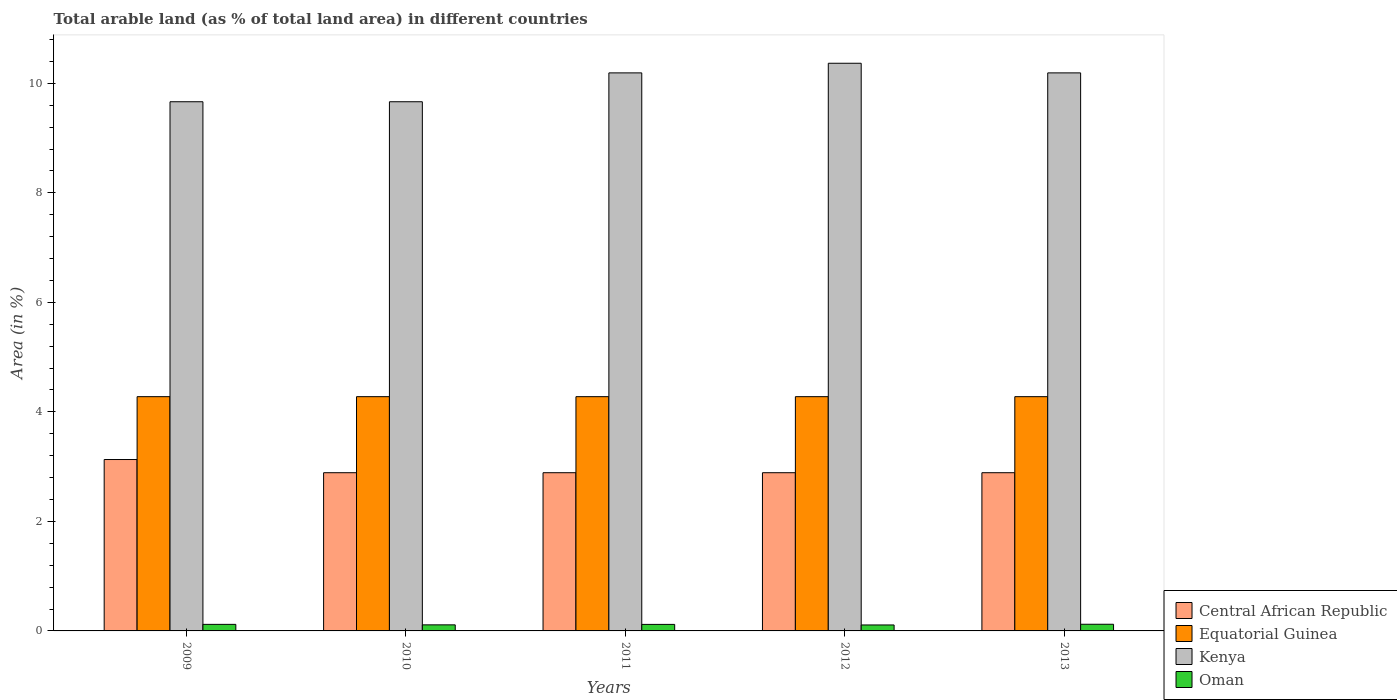How many groups of bars are there?
Provide a succinct answer. 5. Are the number of bars on each tick of the X-axis equal?
Your answer should be very brief. Yes. How many bars are there on the 3rd tick from the left?
Ensure brevity in your answer.  4. What is the label of the 4th group of bars from the left?
Provide a succinct answer. 2012. In how many cases, is the number of bars for a given year not equal to the number of legend labels?
Ensure brevity in your answer.  0. What is the percentage of arable land in Central African Republic in 2013?
Provide a short and direct response. 2.89. Across all years, what is the maximum percentage of arable land in Oman?
Offer a very short reply. 0.12. Across all years, what is the minimum percentage of arable land in Central African Republic?
Make the answer very short. 2.89. What is the total percentage of arable land in Central African Republic in the graph?
Provide a short and direct response. 14.69. What is the difference between the percentage of arable land in Oman in 2010 and that in 2013?
Keep it short and to the point. -0.01. What is the difference between the percentage of arable land in Equatorial Guinea in 2009 and the percentage of arable land in Kenya in 2013?
Your response must be concise. -5.91. What is the average percentage of arable land in Central African Republic per year?
Provide a succinct answer. 2.94. In the year 2012, what is the difference between the percentage of arable land in Oman and percentage of arable land in Kenya?
Your response must be concise. -10.26. Is the percentage of arable land in Kenya in 2009 less than that in 2012?
Provide a succinct answer. Yes. Is the difference between the percentage of arable land in Oman in 2009 and 2010 greater than the difference between the percentage of arable land in Kenya in 2009 and 2010?
Offer a terse response. Yes. What is the difference between the highest and the second highest percentage of arable land in Kenya?
Offer a terse response. 0.18. In how many years, is the percentage of arable land in Oman greater than the average percentage of arable land in Oman taken over all years?
Provide a short and direct response. 3. Is the sum of the percentage of arable land in Central African Republic in 2011 and 2013 greater than the maximum percentage of arable land in Kenya across all years?
Offer a terse response. No. What does the 1st bar from the left in 2013 represents?
Offer a very short reply. Central African Republic. What does the 2nd bar from the right in 2012 represents?
Keep it short and to the point. Kenya. How many bars are there?
Provide a short and direct response. 20. Are all the bars in the graph horizontal?
Your response must be concise. No. How many years are there in the graph?
Offer a terse response. 5. What is the difference between two consecutive major ticks on the Y-axis?
Ensure brevity in your answer.  2. Are the values on the major ticks of Y-axis written in scientific E-notation?
Provide a short and direct response. No. Where does the legend appear in the graph?
Offer a very short reply. Bottom right. What is the title of the graph?
Give a very brief answer. Total arable land (as % of total land area) in different countries. What is the label or title of the Y-axis?
Ensure brevity in your answer.  Area (in %). What is the Area (in %) of Central African Republic in 2009?
Provide a short and direct response. 3.13. What is the Area (in %) of Equatorial Guinea in 2009?
Offer a very short reply. 4.28. What is the Area (in %) of Kenya in 2009?
Offer a very short reply. 9.66. What is the Area (in %) in Oman in 2009?
Ensure brevity in your answer.  0.12. What is the Area (in %) of Central African Republic in 2010?
Your response must be concise. 2.89. What is the Area (in %) of Equatorial Guinea in 2010?
Keep it short and to the point. 4.28. What is the Area (in %) in Kenya in 2010?
Offer a terse response. 9.66. What is the Area (in %) in Oman in 2010?
Provide a succinct answer. 0.11. What is the Area (in %) in Central African Republic in 2011?
Give a very brief answer. 2.89. What is the Area (in %) in Equatorial Guinea in 2011?
Offer a terse response. 4.28. What is the Area (in %) in Kenya in 2011?
Your response must be concise. 10.19. What is the Area (in %) in Oman in 2011?
Offer a very short reply. 0.12. What is the Area (in %) of Central African Republic in 2012?
Your answer should be very brief. 2.89. What is the Area (in %) of Equatorial Guinea in 2012?
Provide a succinct answer. 4.28. What is the Area (in %) in Kenya in 2012?
Provide a short and direct response. 10.37. What is the Area (in %) in Oman in 2012?
Offer a terse response. 0.11. What is the Area (in %) of Central African Republic in 2013?
Your answer should be very brief. 2.89. What is the Area (in %) of Equatorial Guinea in 2013?
Provide a short and direct response. 4.28. What is the Area (in %) of Kenya in 2013?
Keep it short and to the point. 10.19. What is the Area (in %) in Oman in 2013?
Make the answer very short. 0.12. Across all years, what is the maximum Area (in %) of Central African Republic?
Your response must be concise. 3.13. Across all years, what is the maximum Area (in %) in Equatorial Guinea?
Ensure brevity in your answer.  4.28. Across all years, what is the maximum Area (in %) of Kenya?
Your answer should be compact. 10.37. Across all years, what is the maximum Area (in %) in Oman?
Provide a succinct answer. 0.12. Across all years, what is the minimum Area (in %) in Central African Republic?
Make the answer very short. 2.89. Across all years, what is the minimum Area (in %) in Equatorial Guinea?
Ensure brevity in your answer.  4.28. Across all years, what is the minimum Area (in %) of Kenya?
Your answer should be very brief. 9.66. Across all years, what is the minimum Area (in %) in Oman?
Your response must be concise. 0.11. What is the total Area (in %) of Central African Republic in the graph?
Your response must be concise. 14.69. What is the total Area (in %) of Equatorial Guinea in the graph?
Provide a short and direct response. 21.39. What is the total Area (in %) of Kenya in the graph?
Offer a terse response. 50.08. What is the total Area (in %) of Oman in the graph?
Make the answer very short. 0.58. What is the difference between the Area (in %) in Central African Republic in 2009 and that in 2010?
Offer a terse response. 0.24. What is the difference between the Area (in %) in Oman in 2009 and that in 2010?
Provide a short and direct response. 0.01. What is the difference between the Area (in %) of Central African Republic in 2009 and that in 2011?
Your answer should be very brief. 0.24. What is the difference between the Area (in %) in Equatorial Guinea in 2009 and that in 2011?
Give a very brief answer. 0. What is the difference between the Area (in %) of Kenya in 2009 and that in 2011?
Provide a short and direct response. -0.53. What is the difference between the Area (in %) of Oman in 2009 and that in 2011?
Your answer should be very brief. 0. What is the difference between the Area (in %) in Central African Republic in 2009 and that in 2012?
Provide a succinct answer. 0.24. What is the difference between the Area (in %) of Kenya in 2009 and that in 2012?
Your answer should be very brief. -0.7. What is the difference between the Area (in %) in Oman in 2009 and that in 2012?
Offer a very short reply. 0.01. What is the difference between the Area (in %) in Central African Republic in 2009 and that in 2013?
Your answer should be very brief. 0.24. What is the difference between the Area (in %) in Equatorial Guinea in 2009 and that in 2013?
Provide a succinct answer. 0. What is the difference between the Area (in %) in Kenya in 2009 and that in 2013?
Provide a short and direct response. -0.53. What is the difference between the Area (in %) in Oman in 2009 and that in 2013?
Your answer should be very brief. -0. What is the difference between the Area (in %) of Kenya in 2010 and that in 2011?
Your answer should be very brief. -0.53. What is the difference between the Area (in %) of Oman in 2010 and that in 2011?
Give a very brief answer. -0.01. What is the difference between the Area (in %) of Equatorial Guinea in 2010 and that in 2012?
Make the answer very short. 0. What is the difference between the Area (in %) in Kenya in 2010 and that in 2012?
Your response must be concise. -0.7. What is the difference between the Area (in %) of Oman in 2010 and that in 2012?
Your answer should be very brief. 0. What is the difference between the Area (in %) of Central African Republic in 2010 and that in 2013?
Offer a terse response. 0. What is the difference between the Area (in %) of Kenya in 2010 and that in 2013?
Your response must be concise. -0.53. What is the difference between the Area (in %) of Oman in 2010 and that in 2013?
Your response must be concise. -0.01. What is the difference between the Area (in %) of Central African Republic in 2011 and that in 2012?
Your response must be concise. 0. What is the difference between the Area (in %) of Kenya in 2011 and that in 2012?
Your answer should be compact. -0.18. What is the difference between the Area (in %) of Oman in 2011 and that in 2012?
Give a very brief answer. 0.01. What is the difference between the Area (in %) of Kenya in 2011 and that in 2013?
Keep it short and to the point. 0. What is the difference between the Area (in %) of Oman in 2011 and that in 2013?
Provide a succinct answer. -0. What is the difference between the Area (in %) in Equatorial Guinea in 2012 and that in 2013?
Give a very brief answer. 0. What is the difference between the Area (in %) in Kenya in 2012 and that in 2013?
Your answer should be very brief. 0.18. What is the difference between the Area (in %) in Oman in 2012 and that in 2013?
Your answer should be very brief. -0.01. What is the difference between the Area (in %) of Central African Republic in 2009 and the Area (in %) of Equatorial Guinea in 2010?
Give a very brief answer. -1.15. What is the difference between the Area (in %) in Central African Republic in 2009 and the Area (in %) in Kenya in 2010?
Ensure brevity in your answer.  -6.53. What is the difference between the Area (in %) of Central African Republic in 2009 and the Area (in %) of Oman in 2010?
Make the answer very short. 3.02. What is the difference between the Area (in %) of Equatorial Guinea in 2009 and the Area (in %) of Kenya in 2010?
Keep it short and to the point. -5.39. What is the difference between the Area (in %) in Equatorial Guinea in 2009 and the Area (in %) in Oman in 2010?
Your answer should be compact. 4.17. What is the difference between the Area (in %) of Kenya in 2009 and the Area (in %) of Oman in 2010?
Provide a short and direct response. 9.55. What is the difference between the Area (in %) in Central African Republic in 2009 and the Area (in %) in Equatorial Guinea in 2011?
Your answer should be compact. -1.15. What is the difference between the Area (in %) in Central African Republic in 2009 and the Area (in %) in Kenya in 2011?
Your answer should be very brief. -7.06. What is the difference between the Area (in %) of Central African Republic in 2009 and the Area (in %) of Oman in 2011?
Ensure brevity in your answer.  3.01. What is the difference between the Area (in %) in Equatorial Guinea in 2009 and the Area (in %) in Kenya in 2011?
Ensure brevity in your answer.  -5.91. What is the difference between the Area (in %) in Equatorial Guinea in 2009 and the Area (in %) in Oman in 2011?
Provide a succinct answer. 4.16. What is the difference between the Area (in %) in Kenya in 2009 and the Area (in %) in Oman in 2011?
Keep it short and to the point. 9.54. What is the difference between the Area (in %) of Central African Republic in 2009 and the Area (in %) of Equatorial Guinea in 2012?
Offer a terse response. -1.15. What is the difference between the Area (in %) of Central African Republic in 2009 and the Area (in %) of Kenya in 2012?
Make the answer very short. -7.24. What is the difference between the Area (in %) of Central African Republic in 2009 and the Area (in %) of Oman in 2012?
Provide a short and direct response. 3.02. What is the difference between the Area (in %) of Equatorial Guinea in 2009 and the Area (in %) of Kenya in 2012?
Your answer should be compact. -6.09. What is the difference between the Area (in %) in Equatorial Guinea in 2009 and the Area (in %) in Oman in 2012?
Make the answer very short. 4.17. What is the difference between the Area (in %) in Kenya in 2009 and the Area (in %) in Oman in 2012?
Offer a terse response. 9.55. What is the difference between the Area (in %) in Central African Republic in 2009 and the Area (in %) in Equatorial Guinea in 2013?
Offer a terse response. -1.15. What is the difference between the Area (in %) of Central African Republic in 2009 and the Area (in %) of Kenya in 2013?
Provide a succinct answer. -7.06. What is the difference between the Area (in %) of Central African Republic in 2009 and the Area (in %) of Oman in 2013?
Your response must be concise. 3.01. What is the difference between the Area (in %) in Equatorial Guinea in 2009 and the Area (in %) in Kenya in 2013?
Keep it short and to the point. -5.91. What is the difference between the Area (in %) of Equatorial Guinea in 2009 and the Area (in %) of Oman in 2013?
Give a very brief answer. 4.16. What is the difference between the Area (in %) of Kenya in 2009 and the Area (in %) of Oman in 2013?
Keep it short and to the point. 9.54. What is the difference between the Area (in %) in Central African Republic in 2010 and the Area (in %) in Equatorial Guinea in 2011?
Give a very brief answer. -1.39. What is the difference between the Area (in %) of Central African Republic in 2010 and the Area (in %) of Kenya in 2011?
Provide a short and direct response. -7.3. What is the difference between the Area (in %) of Central African Republic in 2010 and the Area (in %) of Oman in 2011?
Provide a short and direct response. 2.77. What is the difference between the Area (in %) of Equatorial Guinea in 2010 and the Area (in %) of Kenya in 2011?
Your response must be concise. -5.91. What is the difference between the Area (in %) in Equatorial Guinea in 2010 and the Area (in %) in Oman in 2011?
Give a very brief answer. 4.16. What is the difference between the Area (in %) of Kenya in 2010 and the Area (in %) of Oman in 2011?
Provide a short and direct response. 9.54. What is the difference between the Area (in %) in Central African Republic in 2010 and the Area (in %) in Equatorial Guinea in 2012?
Ensure brevity in your answer.  -1.39. What is the difference between the Area (in %) in Central African Republic in 2010 and the Area (in %) in Kenya in 2012?
Ensure brevity in your answer.  -7.48. What is the difference between the Area (in %) in Central African Republic in 2010 and the Area (in %) in Oman in 2012?
Make the answer very short. 2.78. What is the difference between the Area (in %) of Equatorial Guinea in 2010 and the Area (in %) of Kenya in 2012?
Make the answer very short. -6.09. What is the difference between the Area (in %) of Equatorial Guinea in 2010 and the Area (in %) of Oman in 2012?
Offer a terse response. 4.17. What is the difference between the Area (in %) in Kenya in 2010 and the Area (in %) in Oman in 2012?
Your answer should be very brief. 9.55. What is the difference between the Area (in %) in Central African Republic in 2010 and the Area (in %) in Equatorial Guinea in 2013?
Your answer should be very brief. -1.39. What is the difference between the Area (in %) of Central African Republic in 2010 and the Area (in %) of Kenya in 2013?
Your answer should be very brief. -7.3. What is the difference between the Area (in %) of Central African Republic in 2010 and the Area (in %) of Oman in 2013?
Keep it short and to the point. 2.77. What is the difference between the Area (in %) in Equatorial Guinea in 2010 and the Area (in %) in Kenya in 2013?
Your response must be concise. -5.91. What is the difference between the Area (in %) in Equatorial Guinea in 2010 and the Area (in %) in Oman in 2013?
Keep it short and to the point. 4.16. What is the difference between the Area (in %) in Kenya in 2010 and the Area (in %) in Oman in 2013?
Your response must be concise. 9.54. What is the difference between the Area (in %) of Central African Republic in 2011 and the Area (in %) of Equatorial Guinea in 2012?
Your response must be concise. -1.39. What is the difference between the Area (in %) in Central African Republic in 2011 and the Area (in %) in Kenya in 2012?
Your answer should be compact. -7.48. What is the difference between the Area (in %) in Central African Republic in 2011 and the Area (in %) in Oman in 2012?
Your answer should be compact. 2.78. What is the difference between the Area (in %) in Equatorial Guinea in 2011 and the Area (in %) in Kenya in 2012?
Keep it short and to the point. -6.09. What is the difference between the Area (in %) in Equatorial Guinea in 2011 and the Area (in %) in Oman in 2012?
Your response must be concise. 4.17. What is the difference between the Area (in %) of Kenya in 2011 and the Area (in %) of Oman in 2012?
Give a very brief answer. 10.08. What is the difference between the Area (in %) in Central African Republic in 2011 and the Area (in %) in Equatorial Guinea in 2013?
Offer a very short reply. -1.39. What is the difference between the Area (in %) of Central African Republic in 2011 and the Area (in %) of Kenya in 2013?
Make the answer very short. -7.3. What is the difference between the Area (in %) in Central African Republic in 2011 and the Area (in %) in Oman in 2013?
Offer a terse response. 2.77. What is the difference between the Area (in %) of Equatorial Guinea in 2011 and the Area (in %) of Kenya in 2013?
Ensure brevity in your answer.  -5.91. What is the difference between the Area (in %) of Equatorial Guinea in 2011 and the Area (in %) of Oman in 2013?
Make the answer very short. 4.16. What is the difference between the Area (in %) in Kenya in 2011 and the Area (in %) in Oman in 2013?
Keep it short and to the point. 10.07. What is the difference between the Area (in %) of Central African Republic in 2012 and the Area (in %) of Equatorial Guinea in 2013?
Offer a very short reply. -1.39. What is the difference between the Area (in %) in Central African Republic in 2012 and the Area (in %) in Kenya in 2013?
Provide a succinct answer. -7.3. What is the difference between the Area (in %) of Central African Republic in 2012 and the Area (in %) of Oman in 2013?
Provide a short and direct response. 2.77. What is the difference between the Area (in %) in Equatorial Guinea in 2012 and the Area (in %) in Kenya in 2013?
Your answer should be very brief. -5.91. What is the difference between the Area (in %) of Equatorial Guinea in 2012 and the Area (in %) of Oman in 2013?
Make the answer very short. 4.16. What is the difference between the Area (in %) of Kenya in 2012 and the Area (in %) of Oman in 2013?
Your response must be concise. 10.24. What is the average Area (in %) of Central African Republic per year?
Keep it short and to the point. 2.94. What is the average Area (in %) in Equatorial Guinea per year?
Provide a short and direct response. 4.28. What is the average Area (in %) in Kenya per year?
Your answer should be very brief. 10.02. What is the average Area (in %) of Oman per year?
Ensure brevity in your answer.  0.12. In the year 2009, what is the difference between the Area (in %) of Central African Republic and Area (in %) of Equatorial Guinea?
Provide a succinct answer. -1.15. In the year 2009, what is the difference between the Area (in %) of Central African Republic and Area (in %) of Kenya?
Ensure brevity in your answer.  -6.53. In the year 2009, what is the difference between the Area (in %) of Central African Republic and Area (in %) of Oman?
Give a very brief answer. 3.01. In the year 2009, what is the difference between the Area (in %) in Equatorial Guinea and Area (in %) in Kenya?
Keep it short and to the point. -5.39. In the year 2009, what is the difference between the Area (in %) of Equatorial Guinea and Area (in %) of Oman?
Offer a very short reply. 4.16. In the year 2009, what is the difference between the Area (in %) in Kenya and Area (in %) in Oman?
Make the answer very short. 9.54. In the year 2010, what is the difference between the Area (in %) of Central African Republic and Area (in %) of Equatorial Guinea?
Offer a very short reply. -1.39. In the year 2010, what is the difference between the Area (in %) in Central African Republic and Area (in %) in Kenya?
Keep it short and to the point. -6.77. In the year 2010, what is the difference between the Area (in %) in Central African Republic and Area (in %) in Oman?
Provide a short and direct response. 2.78. In the year 2010, what is the difference between the Area (in %) in Equatorial Guinea and Area (in %) in Kenya?
Your answer should be very brief. -5.39. In the year 2010, what is the difference between the Area (in %) of Equatorial Guinea and Area (in %) of Oman?
Your answer should be compact. 4.17. In the year 2010, what is the difference between the Area (in %) in Kenya and Area (in %) in Oman?
Your response must be concise. 9.55. In the year 2011, what is the difference between the Area (in %) of Central African Republic and Area (in %) of Equatorial Guinea?
Keep it short and to the point. -1.39. In the year 2011, what is the difference between the Area (in %) in Central African Republic and Area (in %) in Kenya?
Make the answer very short. -7.3. In the year 2011, what is the difference between the Area (in %) of Central African Republic and Area (in %) of Oman?
Give a very brief answer. 2.77. In the year 2011, what is the difference between the Area (in %) of Equatorial Guinea and Area (in %) of Kenya?
Keep it short and to the point. -5.91. In the year 2011, what is the difference between the Area (in %) of Equatorial Guinea and Area (in %) of Oman?
Your answer should be compact. 4.16. In the year 2011, what is the difference between the Area (in %) in Kenya and Area (in %) in Oman?
Make the answer very short. 10.07. In the year 2012, what is the difference between the Area (in %) in Central African Republic and Area (in %) in Equatorial Guinea?
Offer a terse response. -1.39. In the year 2012, what is the difference between the Area (in %) in Central African Republic and Area (in %) in Kenya?
Your answer should be very brief. -7.48. In the year 2012, what is the difference between the Area (in %) in Central African Republic and Area (in %) in Oman?
Provide a succinct answer. 2.78. In the year 2012, what is the difference between the Area (in %) of Equatorial Guinea and Area (in %) of Kenya?
Provide a succinct answer. -6.09. In the year 2012, what is the difference between the Area (in %) of Equatorial Guinea and Area (in %) of Oman?
Ensure brevity in your answer.  4.17. In the year 2012, what is the difference between the Area (in %) in Kenya and Area (in %) in Oman?
Make the answer very short. 10.26. In the year 2013, what is the difference between the Area (in %) of Central African Republic and Area (in %) of Equatorial Guinea?
Give a very brief answer. -1.39. In the year 2013, what is the difference between the Area (in %) in Central African Republic and Area (in %) in Kenya?
Your answer should be very brief. -7.3. In the year 2013, what is the difference between the Area (in %) in Central African Republic and Area (in %) in Oman?
Your answer should be very brief. 2.77. In the year 2013, what is the difference between the Area (in %) of Equatorial Guinea and Area (in %) of Kenya?
Give a very brief answer. -5.91. In the year 2013, what is the difference between the Area (in %) in Equatorial Guinea and Area (in %) in Oman?
Your answer should be very brief. 4.16. In the year 2013, what is the difference between the Area (in %) of Kenya and Area (in %) of Oman?
Ensure brevity in your answer.  10.07. What is the ratio of the Area (in %) in Central African Republic in 2009 to that in 2010?
Keep it short and to the point. 1.08. What is the ratio of the Area (in %) of Kenya in 2009 to that in 2010?
Offer a terse response. 1. What is the ratio of the Area (in %) in Oman in 2009 to that in 2010?
Offer a terse response. 1.08. What is the ratio of the Area (in %) of Kenya in 2009 to that in 2011?
Your answer should be compact. 0.95. What is the ratio of the Area (in %) of Central African Republic in 2009 to that in 2012?
Your answer should be very brief. 1.08. What is the ratio of the Area (in %) in Equatorial Guinea in 2009 to that in 2012?
Ensure brevity in your answer.  1. What is the ratio of the Area (in %) of Kenya in 2009 to that in 2012?
Offer a very short reply. 0.93. What is the ratio of the Area (in %) in Oman in 2009 to that in 2012?
Offer a very short reply. 1.1. What is the ratio of the Area (in %) in Central African Republic in 2009 to that in 2013?
Your response must be concise. 1.08. What is the ratio of the Area (in %) of Equatorial Guinea in 2009 to that in 2013?
Give a very brief answer. 1. What is the ratio of the Area (in %) in Kenya in 2009 to that in 2013?
Make the answer very short. 0.95. What is the ratio of the Area (in %) of Oman in 2009 to that in 2013?
Ensure brevity in your answer.  0.98. What is the ratio of the Area (in %) in Equatorial Guinea in 2010 to that in 2011?
Keep it short and to the point. 1. What is the ratio of the Area (in %) in Kenya in 2010 to that in 2011?
Ensure brevity in your answer.  0.95. What is the ratio of the Area (in %) in Oman in 2010 to that in 2011?
Your answer should be very brief. 0.93. What is the ratio of the Area (in %) in Equatorial Guinea in 2010 to that in 2012?
Provide a succinct answer. 1. What is the ratio of the Area (in %) of Kenya in 2010 to that in 2012?
Ensure brevity in your answer.  0.93. What is the ratio of the Area (in %) in Oman in 2010 to that in 2012?
Keep it short and to the point. 1.02. What is the ratio of the Area (in %) in Equatorial Guinea in 2010 to that in 2013?
Your response must be concise. 1. What is the ratio of the Area (in %) in Kenya in 2010 to that in 2013?
Your response must be concise. 0.95. What is the ratio of the Area (in %) of Oman in 2010 to that in 2013?
Your answer should be very brief. 0.91. What is the ratio of the Area (in %) in Kenya in 2011 to that in 2012?
Give a very brief answer. 0.98. What is the ratio of the Area (in %) of Oman in 2011 to that in 2012?
Make the answer very short. 1.09. What is the ratio of the Area (in %) in Central African Republic in 2011 to that in 2013?
Provide a succinct answer. 1. What is the ratio of the Area (in %) of Kenya in 2011 to that in 2013?
Provide a succinct answer. 1. What is the ratio of the Area (in %) in Oman in 2011 to that in 2013?
Provide a succinct answer. 0.98. What is the ratio of the Area (in %) of Central African Republic in 2012 to that in 2013?
Provide a short and direct response. 1. What is the ratio of the Area (in %) of Equatorial Guinea in 2012 to that in 2013?
Your answer should be compact. 1. What is the ratio of the Area (in %) of Kenya in 2012 to that in 2013?
Your response must be concise. 1.02. What is the ratio of the Area (in %) in Oman in 2012 to that in 2013?
Your answer should be compact. 0.89. What is the difference between the highest and the second highest Area (in %) of Central African Republic?
Provide a short and direct response. 0.24. What is the difference between the highest and the second highest Area (in %) of Equatorial Guinea?
Your response must be concise. 0. What is the difference between the highest and the second highest Area (in %) of Kenya?
Your answer should be compact. 0.18. What is the difference between the highest and the second highest Area (in %) of Oman?
Your answer should be very brief. 0. What is the difference between the highest and the lowest Area (in %) of Central African Republic?
Give a very brief answer. 0.24. What is the difference between the highest and the lowest Area (in %) in Kenya?
Keep it short and to the point. 0.7. What is the difference between the highest and the lowest Area (in %) of Oman?
Provide a short and direct response. 0.01. 